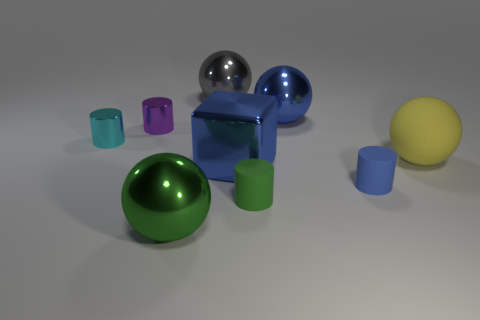Subtract all cylinders. How many objects are left? 5 Subtract all blue matte balls. Subtract all tiny shiny objects. How many objects are left? 7 Add 3 blue balls. How many blue balls are left? 4 Add 6 small yellow cylinders. How many small yellow cylinders exist? 6 Subtract 0 brown cubes. How many objects are left? 9 